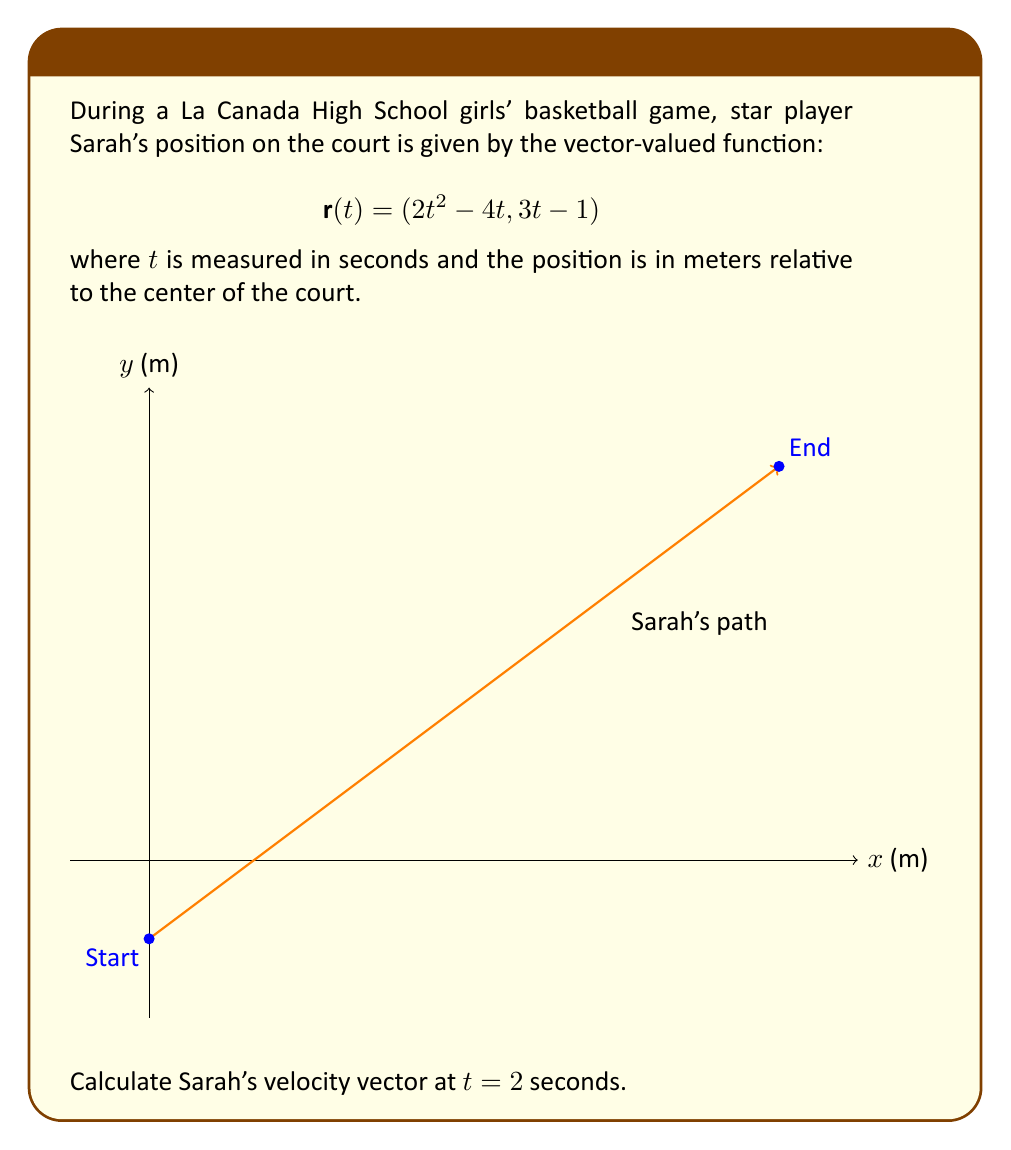What is the answer to this math problem? To find Sarah's velocity vector, we need to differentiate the position vector $\mathbf{r}(t)$ with respect to time $t$. The velocity vector is given by $\mathbf{v}(t) = \frac{d\mathbf{r}}{dt}$.

Let's break it down step-by-step:

1) The position vector is $\mathbf{r}(t) = (2t^2 - 4t, 3t - 1)$

2) To find the velocity vector, we differentiate each component:
   
   $\frac{d}{dt}(2t^2 - 4t) = 4t - 4$
   $\frac{d}{dt}(3t - 1) = 3$

3) Therefore, the velocity vector is:
   
   $\mathbf{v}(t) = (4t - 4, 3)$

4) We need to find the velocity at $t = 2$ seconds:
   
   $\mathbf{v}(2) = (4(2) - 4, 3) = (4, 3)$

5) This means that at $t = 2$ seconds, Sarah is moving 4 meters per second in the x-direction and 3 meters per second in the y-direction.

6) We can also calculate the magnitude of the velocity vector:
   
   $|\mathbf{v}(2)| = \sqrt{4^2 + 3^2} = \sqrt{25} = 5$ m/s

So, Sarah's speed at this moment is 5 meters per second.
Answer: $\mathbf{v}(2) = (4, 3)$ m/s 